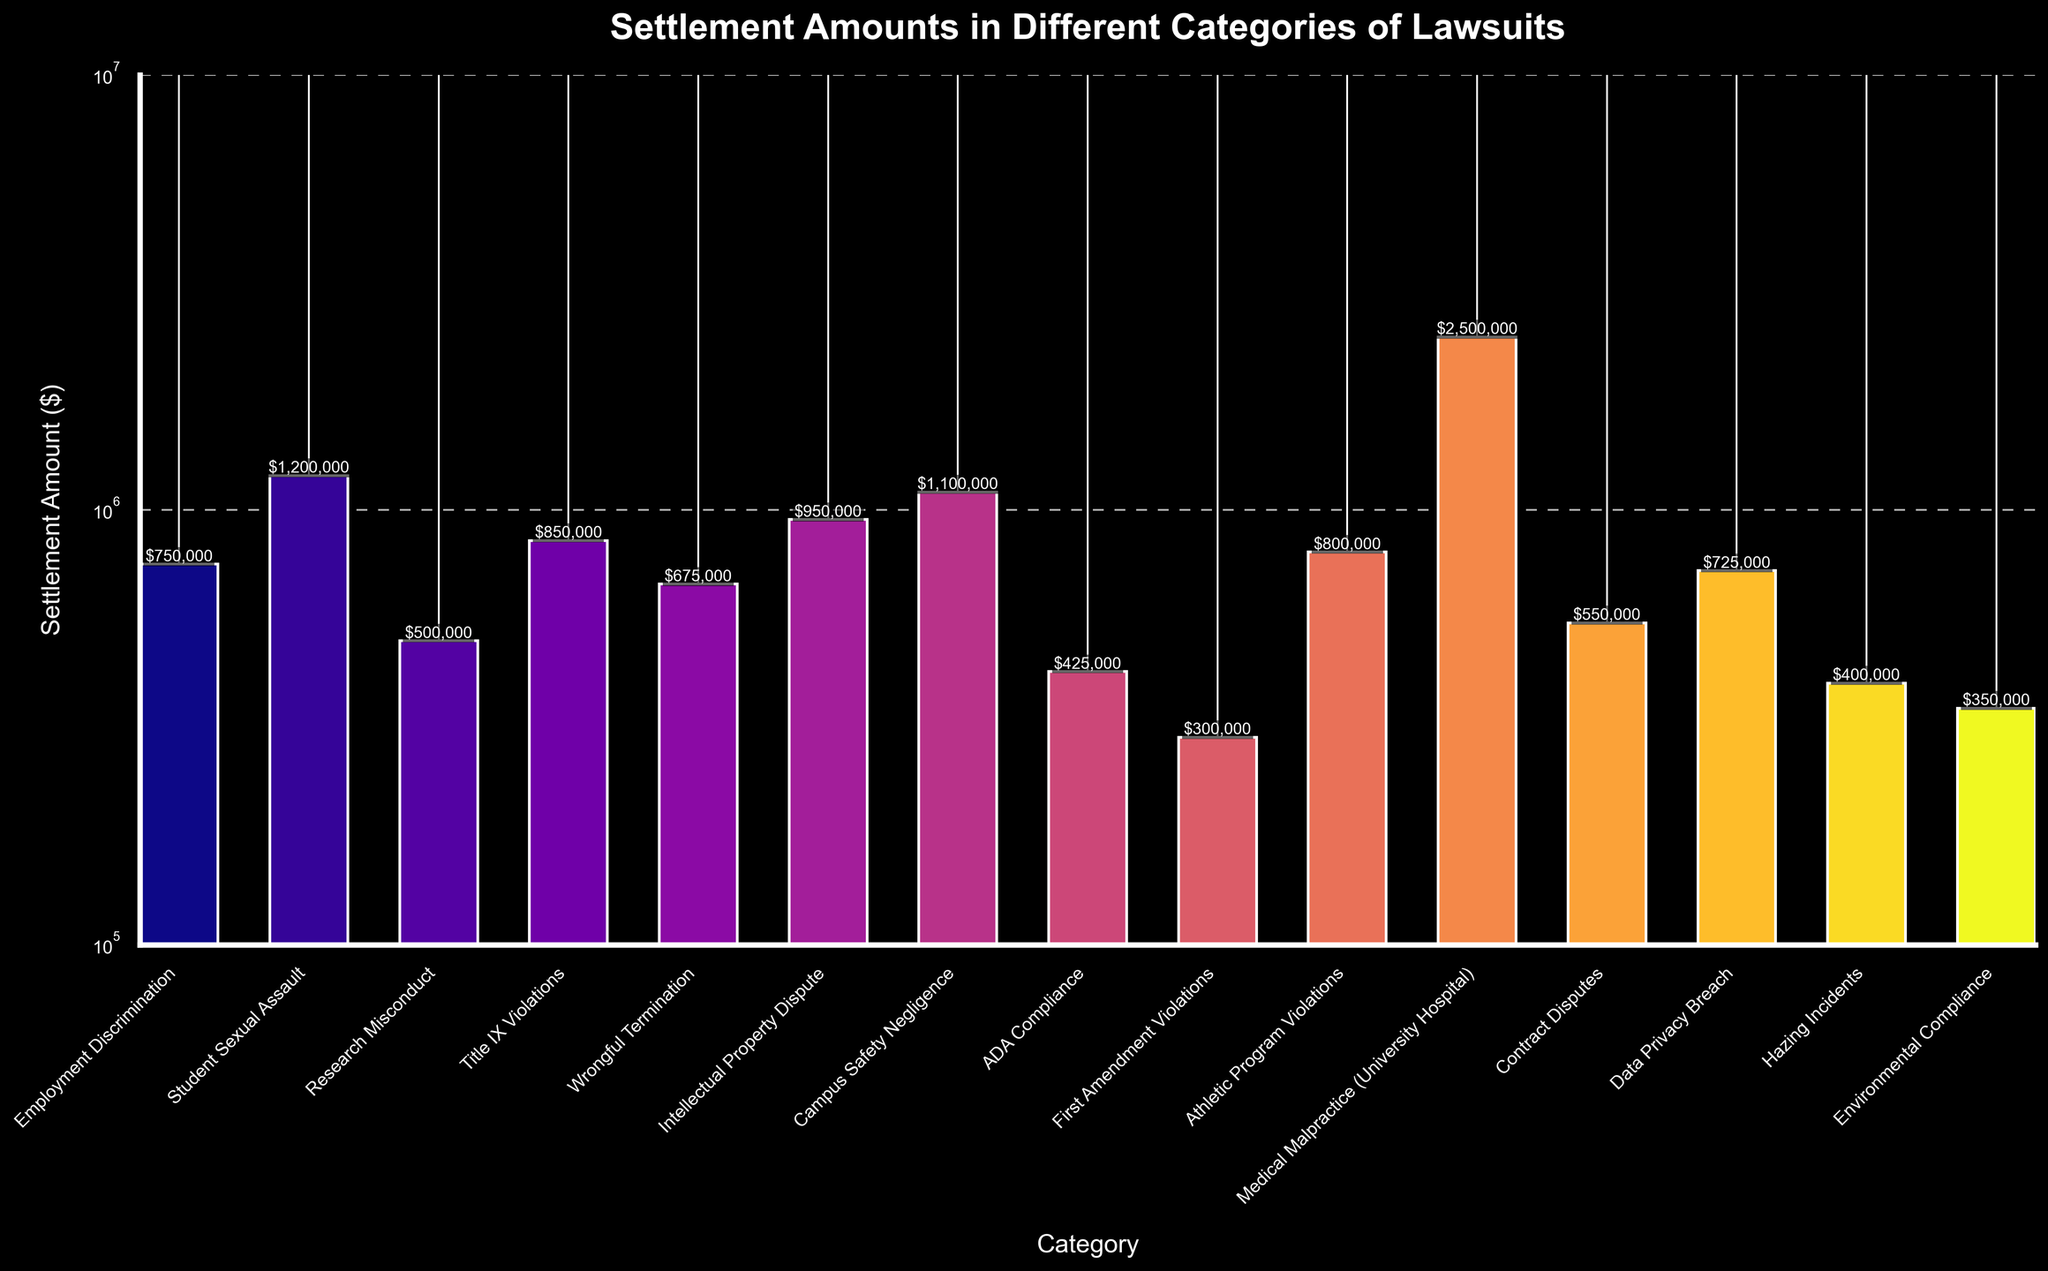Which category has the highest settlement amount? The visual inspection shows that the "Medical Malpractice (University Hospital)" bar is the tallest, indicating it has the highest settlement amount.
Answer: Medical Malpractice (University Hospital) What is the difference in settlement amounts between "Student Sexual Assault" and "Title IX Violations"? The settlement amount for "Student Sexual Assault" is $1,200,000, and for "Title IX Violations" it is $850,000. The difference is calculated as $1,200,000 - $850,000.
Answer: $350,000 Which categories have a settlement amount greater than $1,000,000? Bars for "Student Sexual Assault", "Campus Safety Negligence", and "Medical Malpractice (University Hospital)" extend above $1,000,000 on the y-axis.
Answer: Student Sexual Assault, Campus Safety Negligence, Medical Malpractice (University Hospital) What is the total settlement amount for "ADA Compliance" and "Data Privacy Breach"? The settlement amount for "ADA Compliance" is $425,000 and for "Data Privacy Breach" is $725,000. Summing these gives $425,000 + $725,000.
Answer: $1,150,000 Which category has the lowest settlement amount, and what is it? The bar for "First Amendment Violations" is the shortest, indicating the lowest settlement amount.
Answer: First Amendment Violations, $300,000 What is the combined settlement amount for "Wrongful Termination", "Intellectual Property Dispute", and "Research Misconduct"? The settlement amounts are $675,000 for "Wrongful Termination", $950,000 for "Intellectual Property Dispute", and $500,000 for "Research Misconduct". The combined total is $675,000 + $950,000 + $500,000.
Answer: $2,125,000 Compare the settlement amounts of "Environmental Compliance" and "Hazing Incidents". Which is higher and by how much? The settlement amount for "Hazing Incidents" is $400,000 and for "Environmental Compliance" is $350,000. The difference is $400,000 - $350,000.
Answer: Hazing Incidents, $50,000 Which bar is colored the darkest, and what category does it represent? As the colors are on a spectrum, the bar representing "Environmental Compliance" appears to be the darkest.
Answer: Environmental Compliance What is the median settlement amount across all categories? Ordering the amounts: $300,000, $350,000, $400,000, $425,000, $500,000, $550,000, $675,000, $725,000, $750,000, $800,000, $850,000, $950,000, $1,100,000, $1,200,000, $2,500,000. The median value is the 8th value in the list.
Answer: $725,000 